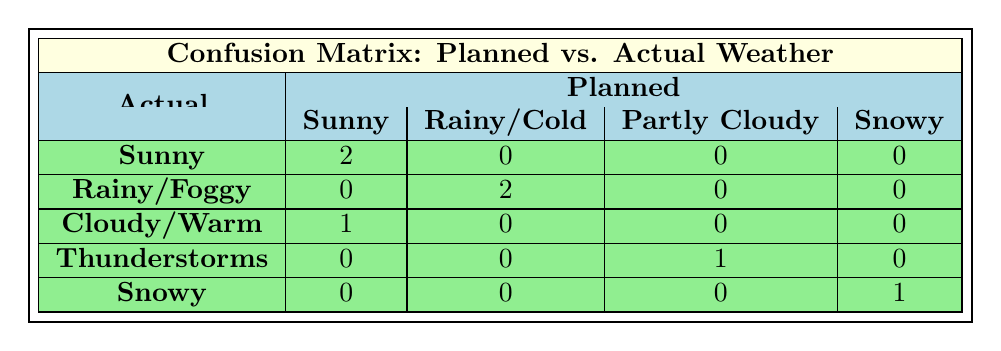What is the number of weddings where the actual weather was sunny? From the table, we can see that there are 2 instances where the actual weather matches sunny under planned weather, indicating two weddings experienced sunny weather.
Answer: 2 How many weddings planned for rainy weather had a different actual weather outcome? Looking at the table, there are 2 instances where weddings planned for rainy weather had different outcomes: one had foggy weather and the other rainy weather. Thus, only the foggy one is not matching.
Answer: 1 What was the actual weather outcome for the planned partly cloudy wedding? The table shows that the only planned partly cloudy wedding resulted in thunderstorms. Therefore, the actual weather was thunderstorms.
Answer: Thunderstorms Is there a wedding that planned for sunny weather but ended up with cloudy weather? According to the table, there is one instance where a wedding planned for sunny weather had an actual weather outcome of cloudy/warm. Thus, the answer is yes.
Answer: Yes What is the sum of all weddings where the planned weather was snowy? From the table, there is only 1 instance where the planned weather was snowy and it indeed matched snowy for actual weather. The sum of weddings planned for snowy weather is thus 1.
Answer: 1 What was the actual weather outcome for the wedding that was planned for cool weather? The table indicates that the actual weather outcome for a wedding planned to be cool resulted in warm conditions. This means the actual weather was warm.
Answer: Warm How many weddings had their actual weather match what was planned? By reviewing the table, we can count the matches: 2 sunny, 1 snowy, and the rainy weather also matches, totaling 4 weddings where actual matches were planned.
Answer: 4 Did any wedding planned for sunny weather experience thunderstorms? The table indicates that no weddings planned for sunny weather experienced thunderstorms; in fact, there are only sunny outcomes for planned sunny weather.
Answer: No What is the difference between the number of weddings with sunny and rainy planned weather outcomes? In the table, there are 3 weddings planned for sunny weather which achieved that outcome, while only 2 were planned for rainy. The difference is 3 - 2 = 1 wedding.
Answer: 1 